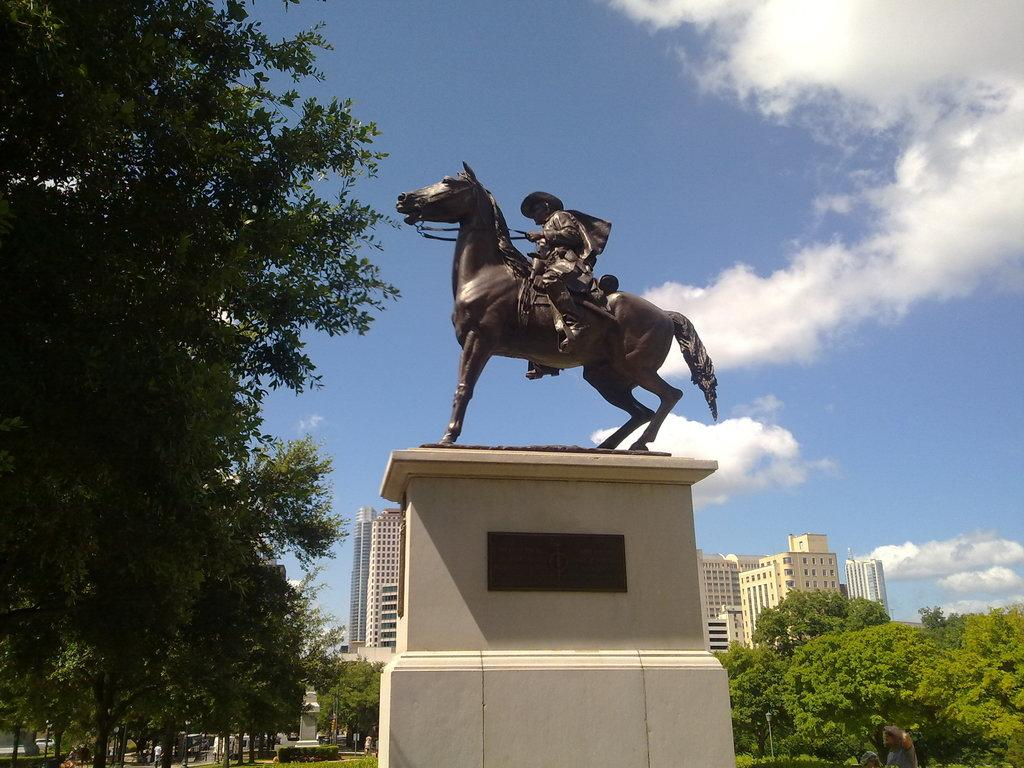What is the main subject in the middle of the image? There is a statue of a man on a horse in the middle of the image. What type of vegetation is present on either side of the statue? There are trees on either side of the statue. What structures can be seen in the background of the image? There are buildings visible at the back of the image. What is visible at the top of the image? The sky is visible at the top of the image. What type of jam is being spread on the potato in the image? There is no jam or potato present in the image; it features a statue of a man on a horse with trees and buildings in the background. 